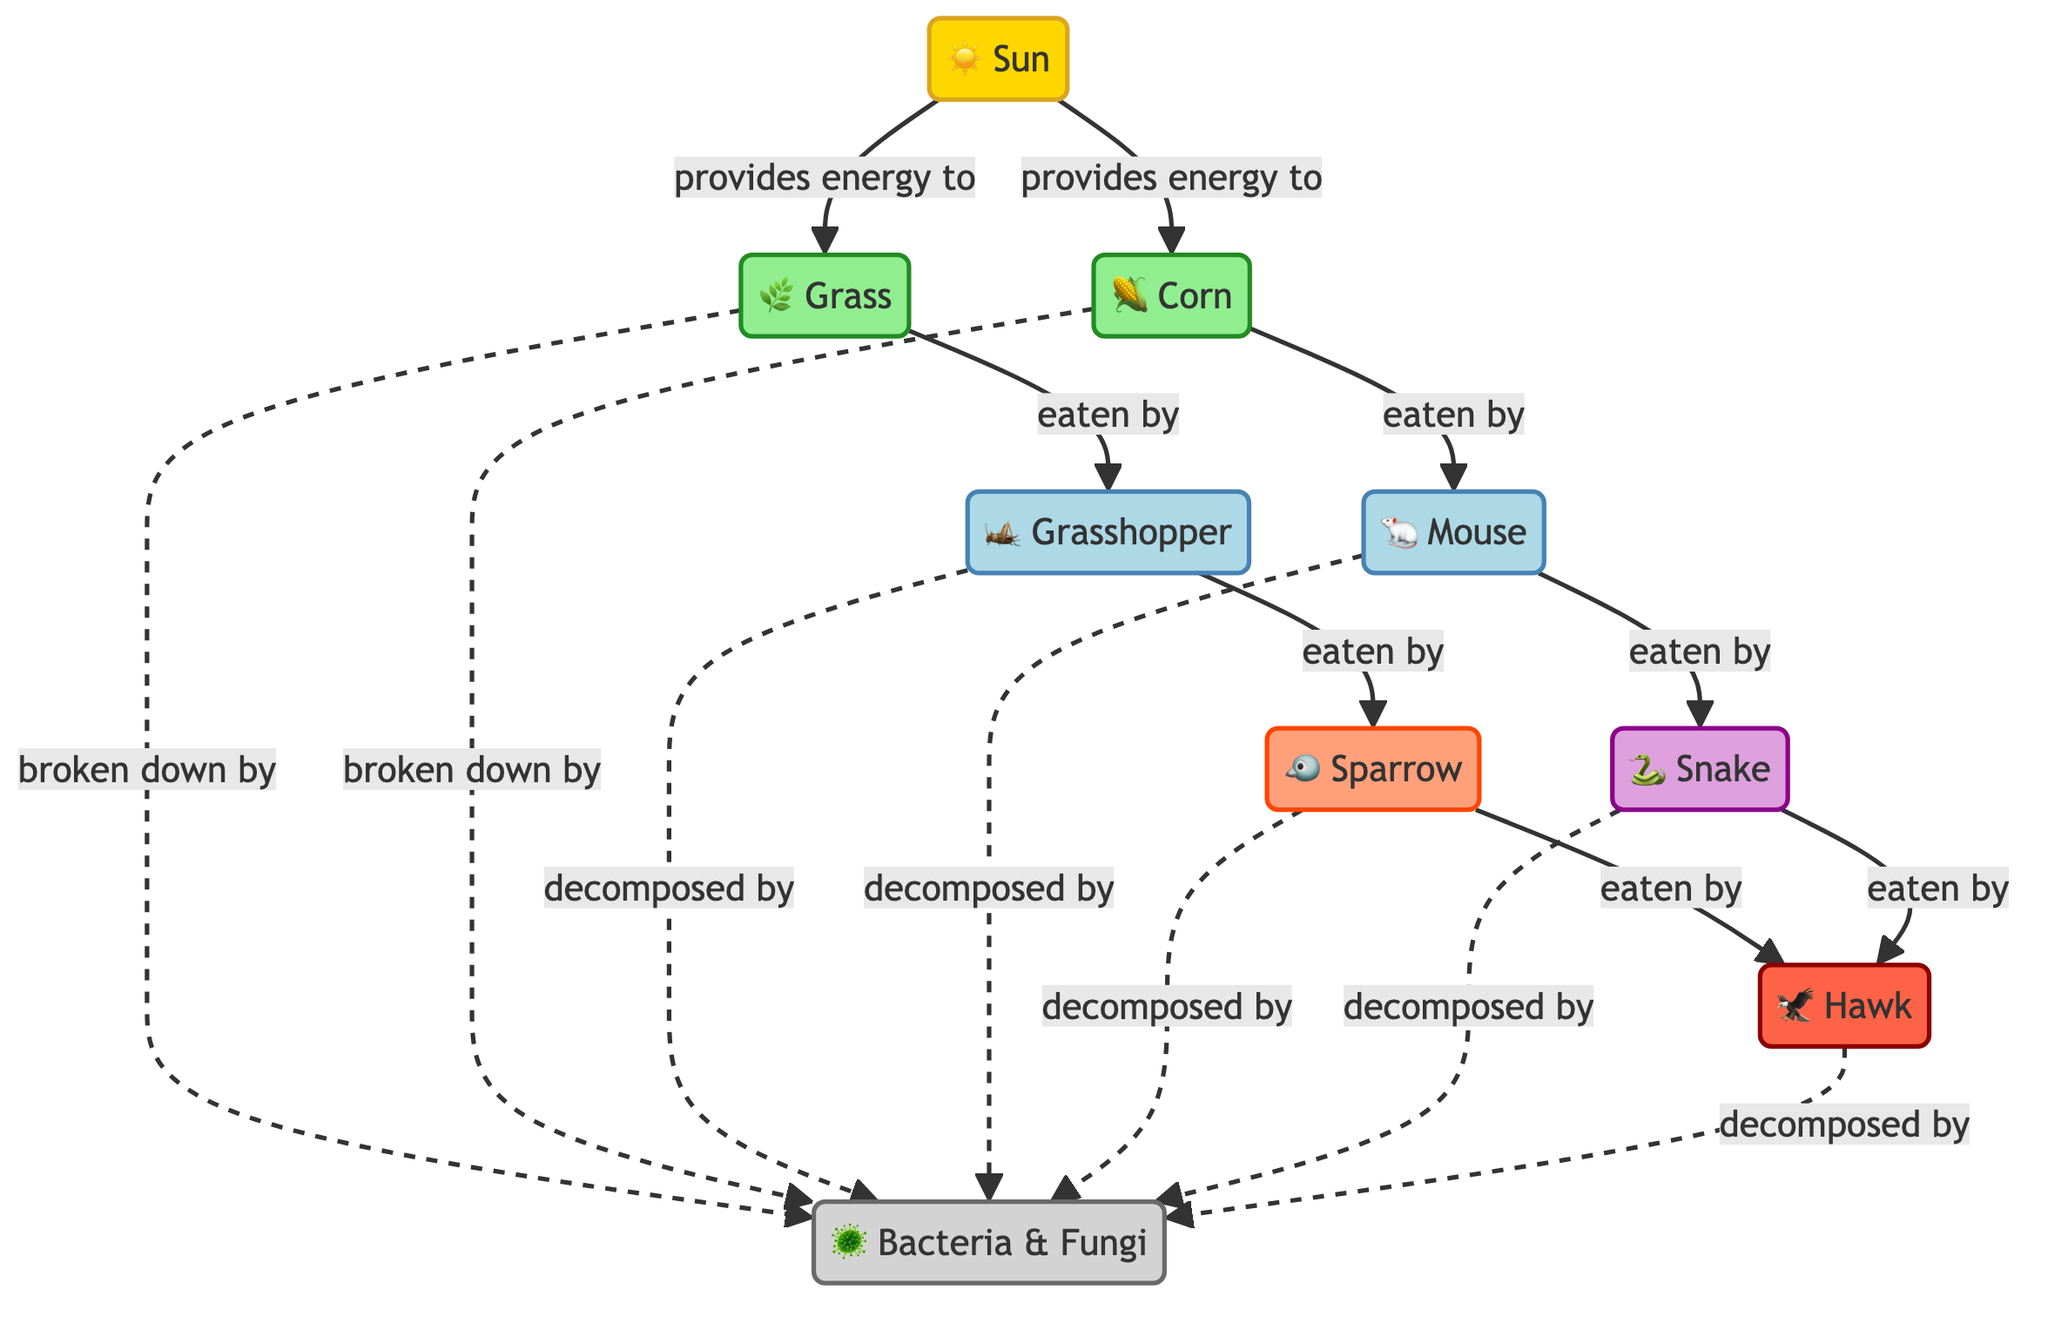What is the primary energy source for the ecosystem? The ecosystem relies on the Sun for energy, which is clearly indicated at the top of the diagram as the initial source providing energy to the plants, in this case, Grass and Corn.
Answer: Sun Which species is directly eaten by the Snake? Looking at the diagram, the only species that is indicated to be directly consumed by the Snake is the Mouse. This can be traced along the arrow from Mouse to Snake.
Answer: Mouse How many primary consumers are present in the diagram? By counting the nodes labeled as primary consumers, we see there are two: the Grasshopper and the Mouse, which are directly eating from producers.
Answer: 2 What is the role of Decomposers in this ecosystem? Decomposers, labeled as Bacteria & Fungi in the diagram, break down dead organic matter, such as Grass, Corn, Grasshopper, Mouse, Sparrow, Snake, and Hawk, returning nutrients to the ecosystem.
Answer: Break down Which animal is the apex predator in this food web? The diagram shows that the Hawk is at the top of the food chain, consuming both the Sparrow and the Snake, making it the apex predator.
Answer: Hawk How many total producers are there in the diagram? The diagram indicates that there are two producers: Grass and Corn. Counting these nodes provides the total number of producers present.
Answer: 2 Which primary consumer is eaten by the Sparrow? The flow in the diagram indicates that the Grasshopper is directly eaten by the Sparrow. Following the arrow from Grasshopper to Sparrow confirms this relationship.
Answer: Grasshopper Which species is a secondary consumer in this food web? By checking the diagram, it is clear that the Sparrow fits the definition of a secondary consumer as it consumes a primary consumer (the Grasshopper).
Answer: Sparrow What relationship exists between the Corn and the Decomposers? The diagram illustrates that Corn is broken down by Decomposers, which is shown with a dashed line indicating that it contributes to nutrient cycling after decomposition.
Answer: Broken down by 